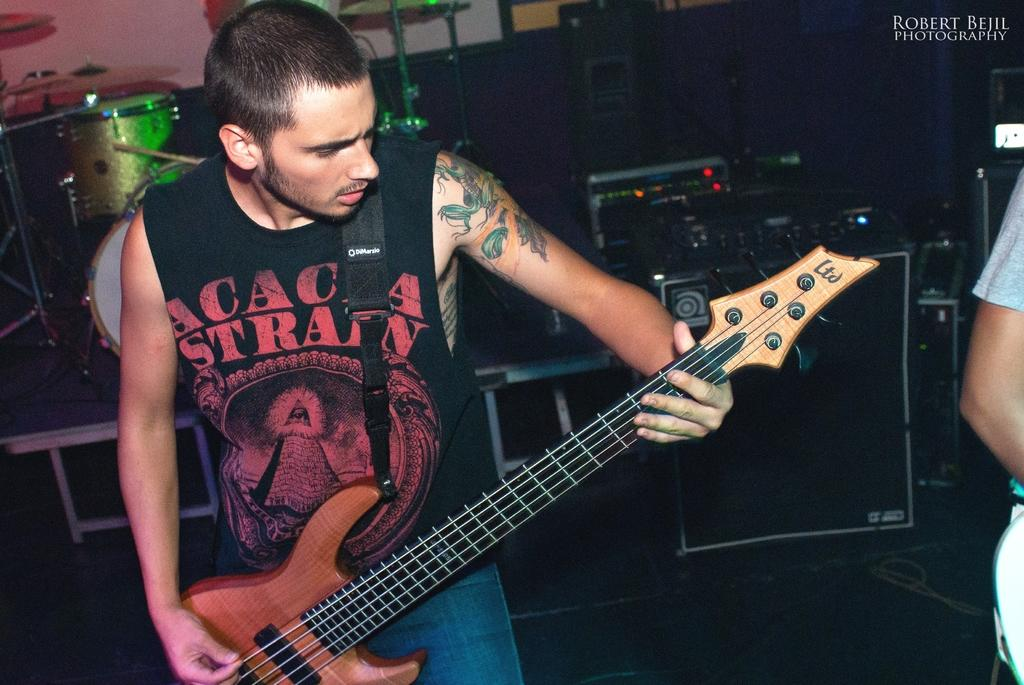What is the man in the image doing? The man is playing the guitar in the image. What instrument is the man holding? The man is holding a guitar. What other musical instruments can be seen in the background of the image? There are electronic drums in the background of the image. What might be used to amplify the sound of the instruments in the image? There are speakers in the background of the image. Can you tell me how many geese are present in the image? There are no geese present in the image. What type of quill is the man using to write music in the image? The man is playing the guitar, not writing music, and there is no quill present in the image. 